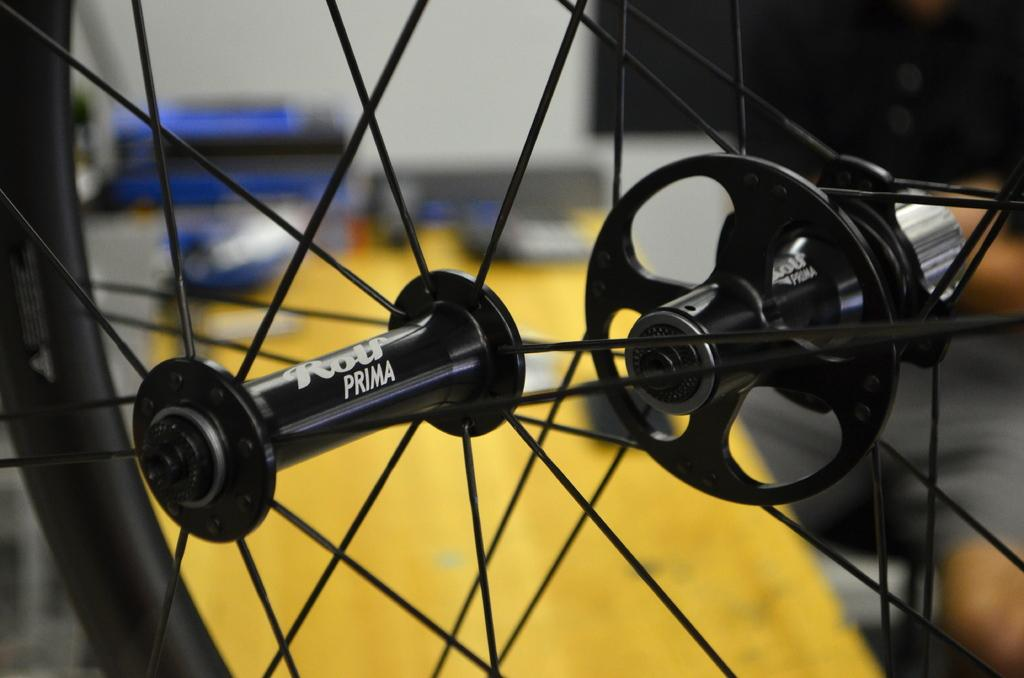What object is the main focus of the image? The main focus of the image is a wheel of a bicycle. Can you describe the background of the image? The background of the image is blurred. How many eggs are visible in the image? There are no eggs present in the image; it only features a wheel of a bicycle and a blurred background. 